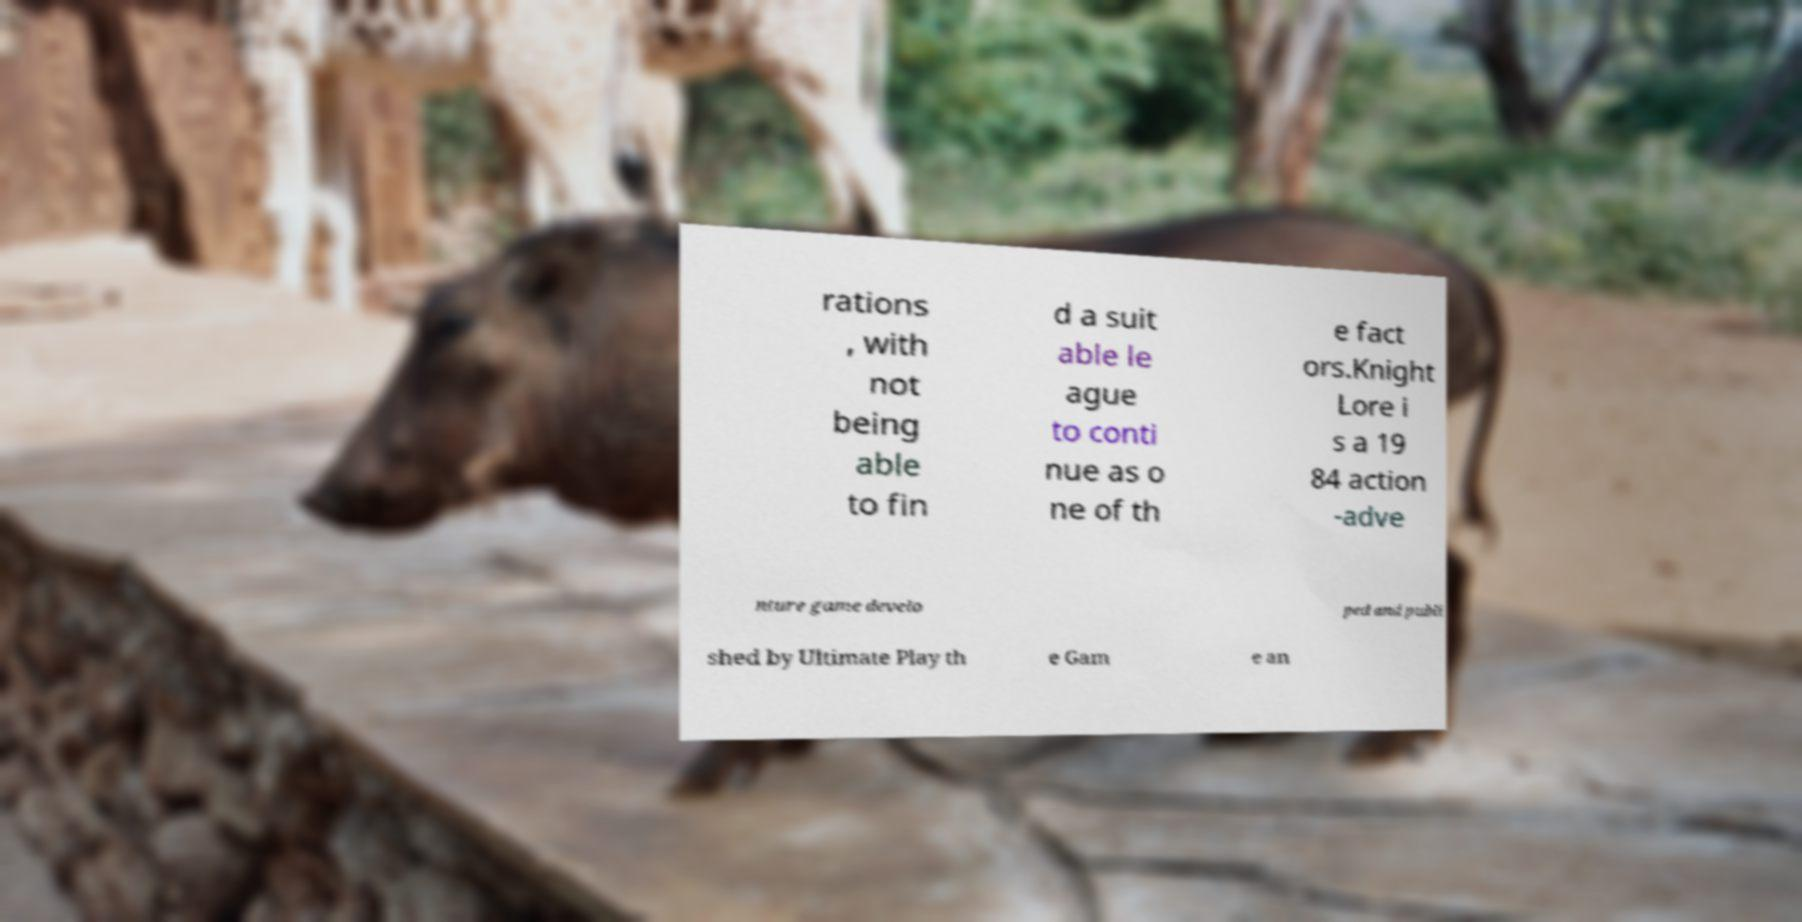Can you accurately transcribe the text from the provided image for me? rations , with not being able to fin d a suit able le ague to conti nue as o ne of th e fact ors.Knight Lore i s a 19 84 action -adve nture game develo ped and publi shed by Ultimate Play th e Gam e an 